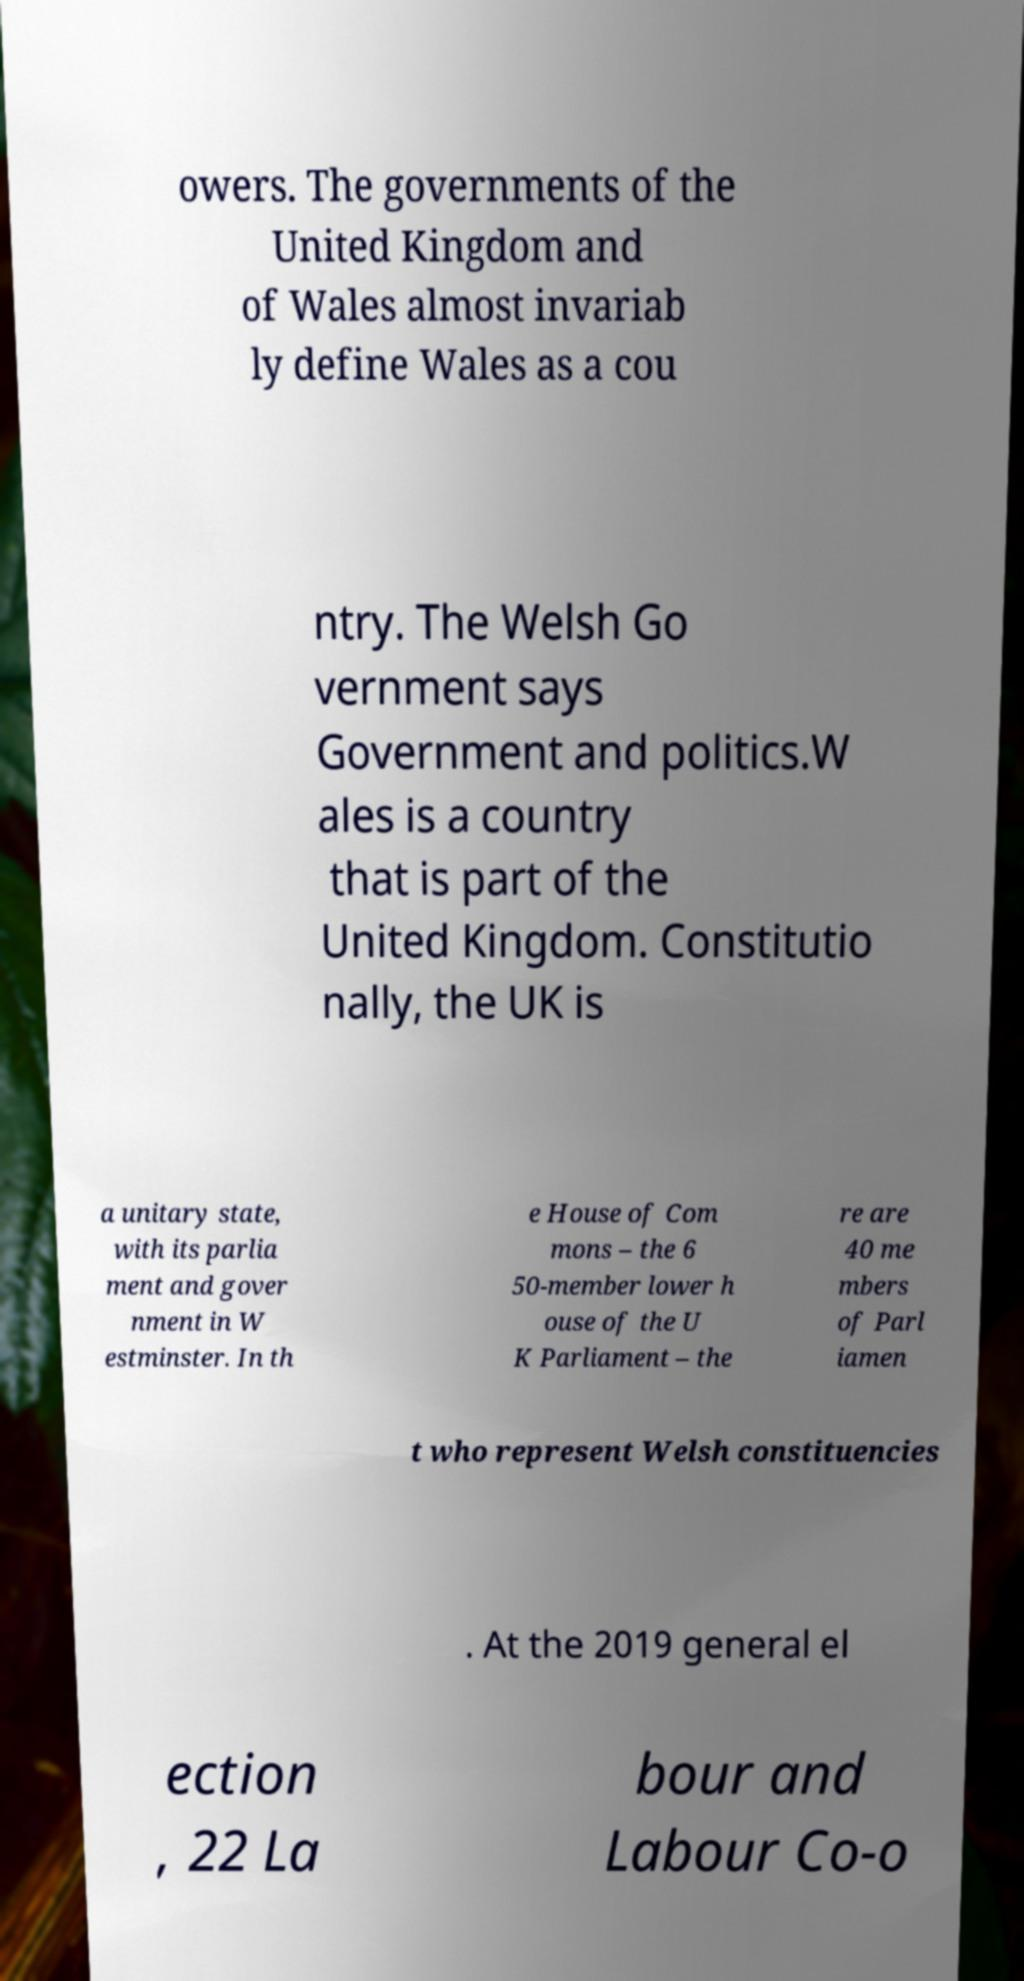What messages or text are displayed in this image? I need them in a readable, typed format. owers. The governments of the United Kingdom and of Wales almost invariab ly define Wales as a cou ntry. The Welsh Go vernment says Government and politics.W ales is a country that is part of the United Kingdom. Constitutio nally, the UK is a unitary state, with its parlia ment and gover nment in W estminster. In th e House of Com mons – the 6 50-member lower h ouse of the U K Parliament – the re are 40 me mbers of Parl iamen t who represent Welsh constituencies . At the 2019 general el ection , 22 La bour and Labour Co-o 